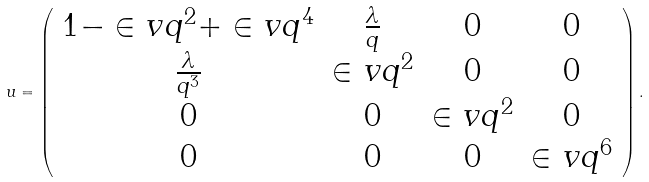Convert formula to latex. <formula><loc_0><loc_0><loc_500><loc_500>u = \left ( \begin{array} { c c c c } 1 - \in v { q ^ { 2 } } + \in v { q ^ { 4 } } & \frac { \lambda } { q } & 0 & 0 \\ \frac { \lambda } { q ^ { 3 } } & \in v { q ^ { 2 } } & 0 & 0 \\ 0 & 0 & \in v { q ^ { 2 } } & 0 \\ 0 & 0 & 0 & \in v { q ^ { 6 } } \end{array} \right ) .</formula> 